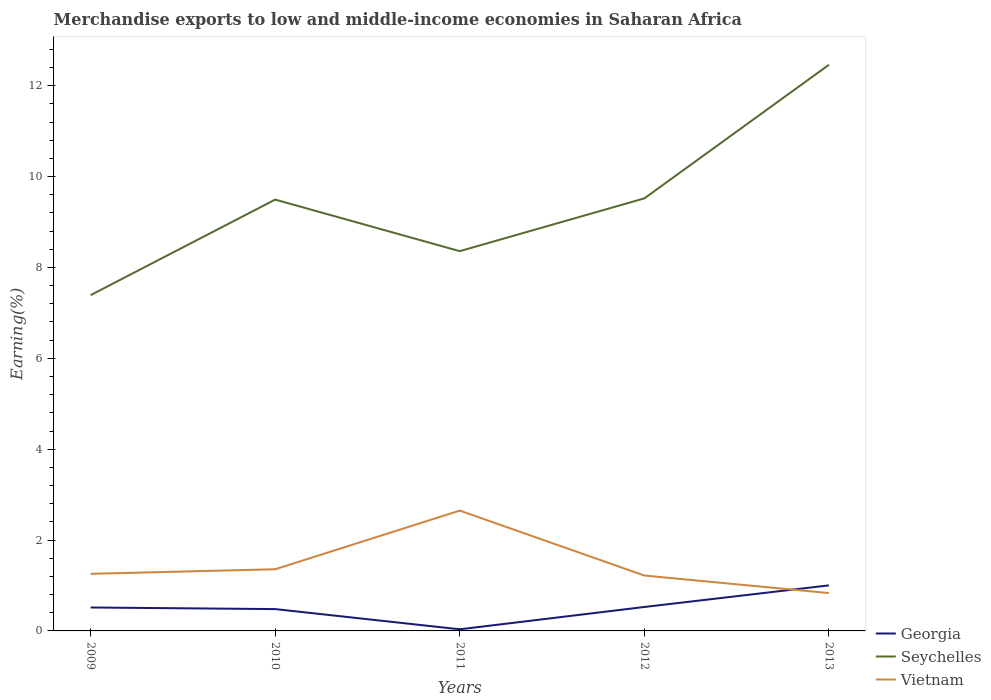Across all years, what is the maximum percentage of amount earned from merchandise exports in Georgia?
Your response must be concise. 0.04. In which year was the percentage of amount earned from merchandise exports in Vietnam maximum?
Give a very brief answer. 2013. What is the total percentage of amount earned from merchandise exports in Vietnam in the graph?
Your answer should be compact. -0.1. What is the difference between the highest and the second highest percentage of amount earned from merchandise exports in Vietnam?
Make the answer very short. 1.82. What is the difference between the highest and the lowest percentage of amount earned from merchandise exports in Georgia?
Ensure brevity in your answer.  3. Is the percentage of amount earned from merchandise exports in Georgia strictly greater than the percentage of amount earned from merchandise exports in Seychelles over the years?
Offer a terse response. Yes. Are the values on the major ticks of Y-axis written in scientific E-notation?
Ensure brevity in your answer.  No. Does the graph contain any zero values?
Your answer should be compact. No. Does the graph contain grids?
Your answer should be compact. No. Where does the legend appear in the graph?
Give a very brief answer. Bottom right. How are the legend labels stacked?
Give a very brief answer. Vertical. What is the title of the graph?
Give a very brief answer. Merchandise exports to low and middle-income economies in Saharan Africa. Does "Nicaragua" appear as one of the legend labels in the graph?
Offer a terse response. No. What is the label or title of the X-axis?
Your answer should be very brief. Years. What is the label or title of the Y-axis?
Offer a terse response. Earning(%). What is the Earning(%) in Georgia in 2009?
Your response must be concise. 0.52. What is the Earning(%) in Seychelles in 2009?
Provide a succinct answer. 7.39. What is the Earning(%) in Vietnam in 2009?
Ensure brevity in your answer.  1.26. What is the Earning(%) of Georgia in 2010?
Make the answer very short. 0.48. What is the Earning(%) of Seychelles in 2010?
Keep it short and to the point. 9.49. What is the Earning(%) in Vietnam in 2010?
Ensure brevity in your answer.  1.36. What is the Earning(%) of Georgia in 2011?
Your response must be concise. 0.04. What is the Earning(%) in Seychelles in 2011?
Your response must be concise. 8.36. What is the Earning(%) of Vietnam in 2011?
Keep it short and to the point. 2.65. What is the Earning(%) of Georgia in 2012?
Provide a short and direct response. 0.53. What is the Earning(%) of Seychelles in 2012?
Ensure brevity in your answer.  9.52. What is the Earning(%) in Vietnam in 2012?
Your response must be concise. 1.22. What is the Earning(%) in Georgia in 2013?
Make the answer very short. 1. What is the Earning(%) of Seychelles in 2013?
Provide a short and direct response. 12.46. What is the Earning(%) of Vietnam in 2013?
Offer a very short reply. 0.83. Across all years, what is the maximum Earning(%) in Georgia?
Offer a terse response. 1. Across all years, what is the maximum Earning(%) in Seychelles?
Keep it short and to the point. 12.46. Across all years, what is the maximum Earning(%) in Vietnam?
Offer a terse response. 2.65. Across all years, what is the minimum Earning(%) of Georgia?
Provide a short and direct response. 0.04. Across all years, what is the minimum Earning(%) in Seychelles?
Provide a short and direct response. 7.39. Across all years, what is the minimum Earning(%) of Vietnam?
Make the answer very short. 0.83. What is the total Earning(%) of Georgia in the graph?
Offer a terse response. 2.56. What is the total Earning(%) of Seychelles in the graph?
Make the answer very short. 47.23. What is the total Earning(%) in Vietnam in the graph?
Ensure brevity in your answer.  7.32. What is the difference between the Earning(%) in Georgia in 2009 and that in 2010?
Your answer should be very brief. 0.04. What is the difference between the Earning(%) of Seychelles in 2009 and that in 2010?
Keep it short and to the point. -2.1. What is the difference between the Earning(%) of Vietnam in 2009 and that in 2010?
Provide a succinct answer. -0.1. What is the difference between the Earning(%) in Georgia in 2009 and that in 2011?
Keep it short and to the point. 0.48. What is the difference between the Earning(%) of Seychelles in 2009 and that in 2011?
Your response must be concise. -0.97. What is the difference between the Earning(%) in Vietnam in 2009 and that in 2011?
Ensure brevity in your answer.  -1.39. What is the difference between the Earning(%) of Georgia in 2009 and that in 2012?
Your answer should be very brief. -0.01. What is the difference between the Earning(%) of Seychelles in 2009 and that in 2012?
Your answer should be compact. -2.13. What is the difference between the Earning(%) in Vietnam in 2009 and that in 2012?
Offer a terse response. 0.04. What is the difference between the Earning(%) in Georgia in 2009 and that in 2013?
Your response must be concise. -0.49. What is the difference between the Earning(%) in Seychelles in 2009 and that in 2013?
Offer a terse response. -5.07. What is the difference between the Earning(%) in Vietnam in 2009 and that in 2013?
Keep it short and to the point. 0.42. What is the difference between the Earning(%) of Georgia in 2010 and that in 2011?
Ensure brevity in your answer.  0.44. What is the difference between the Earning(%) of Seychelles in 2010 and that in 2011?
Ensure brevity in your answer.  1.14. What is the difference between the Earning(%) in Vietnam in 2010 and that in 2011?
Your answer should be compact. -1.29. What is the difference between the Earning(%) of Georgia in 2010 and that in 2012?
Keep it short and to the point. -0.05. What is the difference between the Earning(%) in Seychelles in 2010 and that in 2012?
Give a very brief answer. -0.03. What is the difference between the Earning(%) of Vietnam in 2010 and that in 2012?
Your response must be concise. 0.14. What is the difference between the Earning(%) in Georgia in 2010 and that in 2013?
Ensure brevity in your answer.  -0.52. What is the difference between the Earning(%) in Seychelles in 2010 and that in 2013?
Make the answer very short. -2.97. What is the difference between the Earning(%) in Vietnam in 2010 and that in 2013?
Offer a very short reply. 0.52. What is the difference between the Earning(%) of Georgia in 2011 and that in 2012?
Offer a terse response. -0.49. What is the difference between the Earning(%) in Seychelles in 2011 and that in 2012?
Keep it short and to the point. -1.16. What is the difference between the Earning(%) in Vietnam in 2011 and that in 2012?
Offer a terse response. 1.43. What is the difference between the Earning(%) in Georgia in 2011 and that in 2013?
Give a very brief answer. -0.97. What is the difference between the Earning(%) of Seychelles in 2011 and that in 2013?
Offer a terse response. -4.1. What is the difference between the Earning(%) in Vietnam in 2011 and that in 2013?
Offer a very short reply. 1.82. What is the difference between the Earning(%) in Georgia in 2012 and that in 2013?
Make the answer very short. -0.48. What is the difference between the Earning(%) in Seychelles in 2012 and that in 2013?
Make the answer very short. -2.94. What is the difference between the Earning(%) of Vietnam in 2012 and that in 2013?
Your answer should be compact. 0.39. What is the difference between the Earning(%) in Georgia in 2009 and the Earning(%) in Seychelles in 2010?
Make the answer very short. -8.98. What is the difference between the Earning(%) of Georgia in 2009 and the Earning(%) of Vietnam in 2010?
Your answer should be compact. -0.84. What is the difference between the Earning(%) in Seychelles in 2009 and the Earning(%) in Vietnam in 2010?
Ensure brevity in your answer.  6.03. What is the difference between the Earning(%) of Georgia in 2009 and the Earning(%) of Seychelles in 2011?
Your response must be concise. -7.84. What is the difference between the Earning(%) in Georgia in 2009 and the Earning(%) in Vietnam in 2011?
Your answer should be compact. -2.13. What is the difference between the Earning(%) of Seychelles in 2009 and the Earning(%) of Vietnam in 2011?
Offer a terse response. 4.74. What is the difference between the Earning(%) of Georgia in 2009 and the Earning(%) of Seychelles in 2012?
Offer a very short reply. -9.01. What is the difference between the Earning(%) of Georgia in 2009 and the Earning(%) of Vietnam in 2012?
Ensure brevity in your answer.  -0.7. What is the difference between the Earning(%) in Seychelles in 2009 and the Earning(%) in Vietnam in 2012?
Give a very brief answer. 6.17. What is the difference between the Earning(%) of Georgia in 2009 and the Earning(%) of Seychelles in 2013?
Your response must be concise. -11.95. What is the difference between the Earning(%) of Georgia in 2009 and the Earning(%) of Vietnam in 2013?
Provide a succinct answer. -0.32. What is the difference between the Earning(%) in Seychelles in 2009 and the Earning(%) in Vietnam in 2013?
Your answer should be very brief. 6.56. What is the difference between the Earning(%) of Georgia in 2010 and the Earning(%) of Seychelles in 2011?
Make the answer very short. -7.88. What is the difference between the Earning(%) in Georgia in 2010 and the Earning(%) in Vietnam in 2011?
Offer a terse response. -2.17. What is the difference between the Earning(%) in Seychelles in 2010 and the Earning(%) in Vietnam in 2011?
Provide a succinct answer. 6.85. What is the difference between the Earning(%) in Georgia in 2010 and the Earning(%) in Seychelles in 2012?
Make the answer very short. -9.04. What is the difference between the Earning(%) in Georgia in 2010 and the Earning(%) in Vietnam in 2012?
Your response must be concise. -0.74. What is the difference between the Earning(%) in Seychelles in 2010 and the Earning(%) in Vietnam in 2012?
Provide a short and direct response. 8.28. What is the difference between the Earning(%) in Georgia in 2010 and the Earning(%) in Seychelles in 2013?
Make the answer very short. -11.98. What is the difference between the Earning(%) in Georgia in 2010 and the Earning(%) in Vietnam in 2013?
Your answer should be compact. -0.35. What is the difference between the Earning(%) of Seychelles in 2010 and the Earning(%) of Vietnam in 2013?
Your response must be concise. 8.66. What is the difference between the Earning(%) of Georgia in 2011 and the Earning(%) of Seychelles in 2012?
Ensure brevity in your answer.  -9.49. What is the difference between the Earning(%) in Georgia in 2011 and the Earning(%) in Vietnam in 2012?
Provide a succinct answer. -1.18. What is the difference between the Earning(%) in Seychelles in 2011 and the Earning(%) in Vietnam in 2012?
Offer a terse response. 7.14. What is the difference between the Earning(%) in Georgia in 2011 and the Earning(%) in Seychelles in 2013?
Your answer should be very brief. -12.43. What is the difference between the Earning(%) of Georgia in 2011 and the Earning(%) of Vietnam in 2013?
Provide a succinct answer. -0.8. What is the difference between the Earning(%) in Seychelles in 2011 and the Earning(%) in Vietnam in 2013?
Give a very brief answer. 7.53. What is the difference between the Earning(%) in Georgia in 2012 and the Earning(%) in Seychelles in 2013?
Offer a terse response. -11.93. What is the difference between the Earning(%) in Georgia in 2012 and the Earning(%) in Vietnam in 2013?
Make the answer very short. -0.31. What is the difference between the Earning(%) in Seychelles in 2012 and the Earning(%) in Vietnam in 2013?
Provide a short and direct response. 8.69. What is the average Earning(%) in Georgia per year?
Provide a succinct answer. 0.51. What is the average Earning(%) of Seychelles per year?
Provide a succinct answer. 9.45. What is the average Earning(%) of Vietnam per year?
Make the answer very short. 1.46. In the year 2009, what is the difference between the Earning(%) in Georgia and Earning(%) in Seychelles?
Give a very brief answer. -6.88. In the year 2009, what is the difference between the Earning(%) of Georgia and Earning(%) of Vietnam?
Offer a very short reply. -0.74. In the year 2009, what is the difference between the Earning(%) in Seychelles and Earning(%) in Vietnam?
Provide a short and direct response. 6.13. In the year 2010, what is the difference between the Earning(%) of Georgia and Earning(%) of Seychelles?
Offer a very short reply. -9.01. In the year 2010, what is the difference between the Earning(%) of Georgia and Earning(%) of Vietnam?
Make the answer very short. -0.88. In the year 2010, what is the difference between the Earning(%) in Seychelles and Earning(%) in Vietnam?
Give a very brief answer. 8.14. In the year 2011, what is the difference between the Earning(%) in Georgia and Earning(%) in Seychelles?
Provide a short and direct response. -8.32. In the year 2011, what is the difference between the Earning(%) of Georgia and Earning(%) of Vietnam?
Give a very brief answer. -2.61. In the year 2011, what is the difference between the Earning(%) in Seychelles and Earning(%) in Vietnam?
Your answer should be compact. 5.71. In the year 2012, what is the difference between the Earning(%) of Georgia and Earning(%) of Seychelles?
Offer a very short reply. -8.99. In the year 2012, what is the difference between the Earning(%) in Georgia and Earning(%) in Vietnam?
Your answer should be compact. -0.69. In the year 2012, what is the difference between the Earning(%) in Seychelles and Earning(%) in Vietnam?
Ensure brevity in your answer.  8.3. In the year 2013, what is the difference between the Earning(%) of Georgia and Earning(%) of Seychelles?
Provide a succinct answer. -11.46. In the year 2013, what is the difference between the Earning(%) of Georgia and Earning(%) of Vietnam?
Your response must be concise. 0.17. In the year 2013, what is the difference between the Earning(%) of Seychelles and Earning(%) of Vietnam?
Your answer should be very brief. 11.63. What is the ratio of the Earning(%) of Georgia in 2009 to that in 2010?
Provide a short and direct response. 1.07. What is the ratio of the Earning(%) in Seychelles in 2009 to that in 2010?
Offer a very short reply. 0.78. What is the ratio of the Earning(%) of Vietnam in 2009 to that in 2010?
Offer a very short reply. 0.93. What is the ratio of the Earning(%) of Georgia in 2009 to that in 2011?
Your answer should be compact. 14.51. What is the ratio of the Earning(%) of Seychelles in 2009 to that in 2011?
Your response must be concise. 0.88. What is the ratio of the Earning(%) in Vietnam in 2009 to that in 2011?
Your answer should be very brief. 0.47. What is the ratio of the Earning(%) of Georgia in 2009 to that in 2012?
Your answer should be compact. 0.98. What is the ratio of the Earning(%) of Seychelles in 2009 to that in 2012?
Ensure brevity in your answer.  0.78. What is the ratio of the Earning(%) of Vietnam in 2009 to that in 2012?
Your answer should be very brief. 1.03. What is the ratio of the Earning(%) of Georgia in 2009 to that in 2013?
Your answer should be very brief. 0.51. What is the ratio of the Earning(%) of Seychelles in 2009 to that in 2013?
Offer a terse response. 0.59. What is the ratio of the Earning(%) in Vietnam in 2009 to that in 2013?
Offer a terse response. 1.51. What is the ratio of the Earning(%) of Georgia in 2010 to that in 2011?
Offer a terse response. 13.51. What is the ratio of the Earning(%) of Seychelles in 2010 to that in 2011?
Make the answer very short. 1.14. What is the ratio of the Earning(%) in Vietnam in 2010 to that in 2011?
Give a very brief answer. 0.51. What is the ratio of the Earning(%) of Georgia in 2010 to that in 2012?
Provide a succinct answer. 0.91. What is the ratio of the Earning(%) of Vietnam in 2010 to that in 2012?
Keep it short and to the point. 1.11. What is the ratio of the Earning(%) in Georgia in 2010 to that in 2013?
Make the answer very short. 0.48. What is the ratio of the Earning(%) of Seychelles in 2010 to that in 2013?
Your answer should be compact. 0.76. What is the ratio of the Earning(%) of Vietnam in 2010 to that in 2013?
Your answer should be compact. 1.63. What is the ratio of the Earning(%) of Georgia in 2011 to that in 2012?
Offer a terse response. 0.07. What is the ratio of the Earning(%) in Seychelles in 2011 to that in 2012?
Your answer should be compact. 0.88. What is the ratio of the Earning(%) in Vietnam in 2011 to that in 2012?
Make the answer very short. 2.17. What is the ratio of the Earning(%) in Georgia in 2011 to that in 2013?
Provide a short and direct response. 0.04. What is the ratio of the Earning(%) in Seychelles in 2011 to that in 2013?
Your response must be concise. 0.67. What is the ratio of the Earning(%) of Vietnam in 2011 to that in 2013?
Provide a short and direct response. 3.18. What is the ratio of the Earning(%) in Georgia in 2012 to that in 2013?
Your answer should be very brief. 0.53. What is the ratio of the Earning(%) of Seychelles in 2012 to that in 2013?
Give a very brief answer. 0.76. What is the ratio of the Earning(%) in Vietnam in 2012 to that in 2013?
Your answer should be very brief. 1.46. What is the difference between the highest and the second highest Earning(%) in Georgia?
Your response must be concise. 0.48. What is the difference between the highest and the second highest Earning(%) of Seychelles?
Your response must be concise. 2.94. What is the difference between the highest and the second highest Earning(%) in Vietnam?
Offer a terse response. 1.29. What is the difference between the highest and the lowest Earning(%) in Georgia?
Your response must be concise. 0.97. What is the difference between the highest and the lowest Earning(%) in Seychelles?
Offer a terse response. 5.07. What is the difference between the highest and the lowest Earning(%) in Vietnam?
Give a very brief answer. 1.82. 